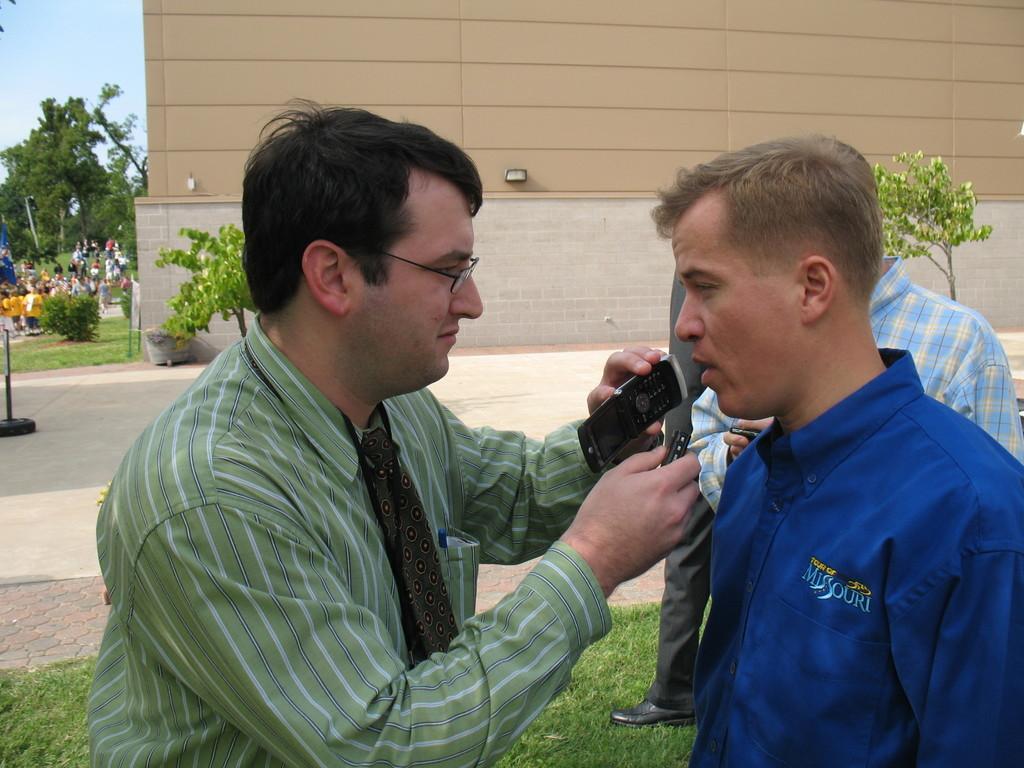Could you give a brief overview of what you see in this image? In this image I can see people are standing among them this man is holding some object in hands. In the background I can see a building, trees, plants, the grass, the sky and other objects on the ground. 